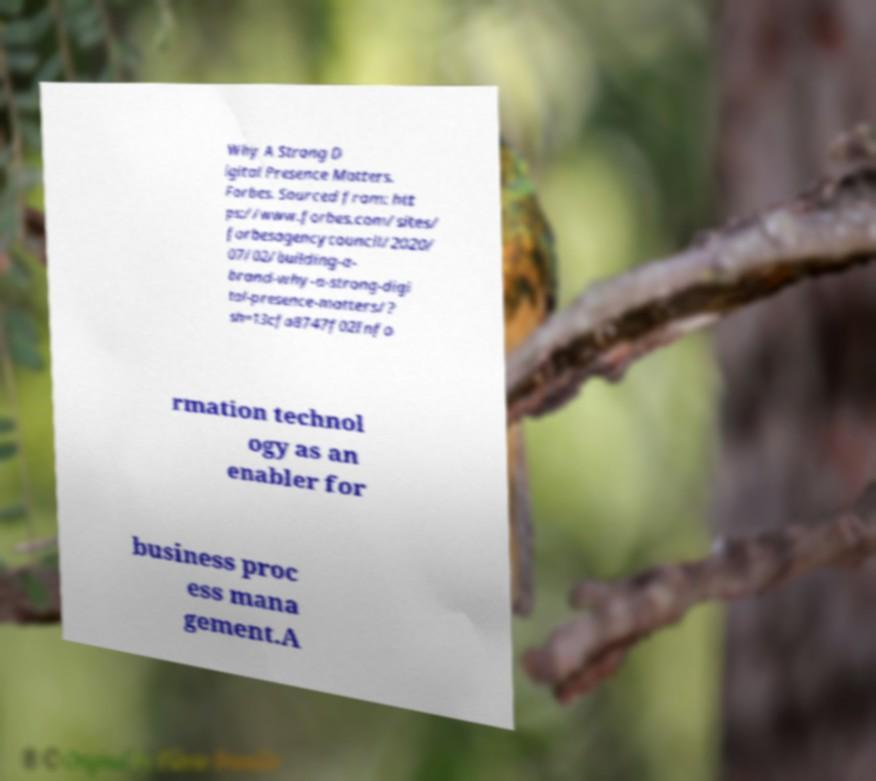Please read and relay the text visible in this image. What does it say? Why A Strong D igital Presence Matters. Forbes. Sourced from: htt ps://www.forbes.com/sites/ forbesagencycouncil/2020/ 07/02/building-a- brand-why-a-strong-digi tal-presence-matters/? sh=13cfa8747f02Info rmation technol ogy as an enabler for business proc ess mana gement.A 